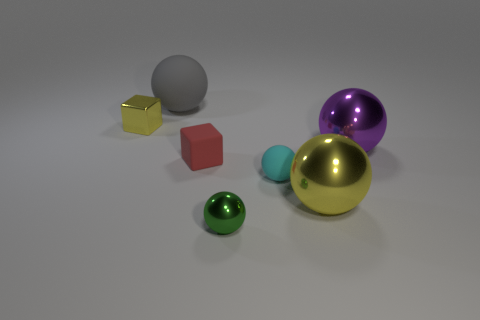Is there a tiny sphere to the left of the ball to the left of the small shiny thing to the right of the yellow block?
Your answer should be very brief. No. What is the size of the purple thing that is made of the same material as the tiny yellow thing?
Keep it short and to the point. Large. Are there any yellow objects to the left of the green shiny sphere?
Keep it short and to the point. Yes. There is a yellow object behind the large yellow sphere; is there a small thing on the right side of it?
Your response must be concise. Yes. Do the rubber ball in front of the big purple metal thing and the shiny thing that is on the right side of the large yellow metal object have the same size?
Give a very brief answer. No. How many large objects are cyan rubber objects or brown rubber cubes?
Keep it short and to the point. 0. What is the tiny block to the right of the large ball to the left of the yellow sphere made of?
Keep it short and to the point. Rubber. What is the shape of the shiny object that is the same color as the shiny cube?
Provide a succinct answer. Sphere. Are there any big yellow spheres made of the same material as the yellow block?
Make the answer very short. Yes. Is the big yellow object made of the same material as the tiny red cube that is behind the big yellow thing?
Your answer should be compact. No. 